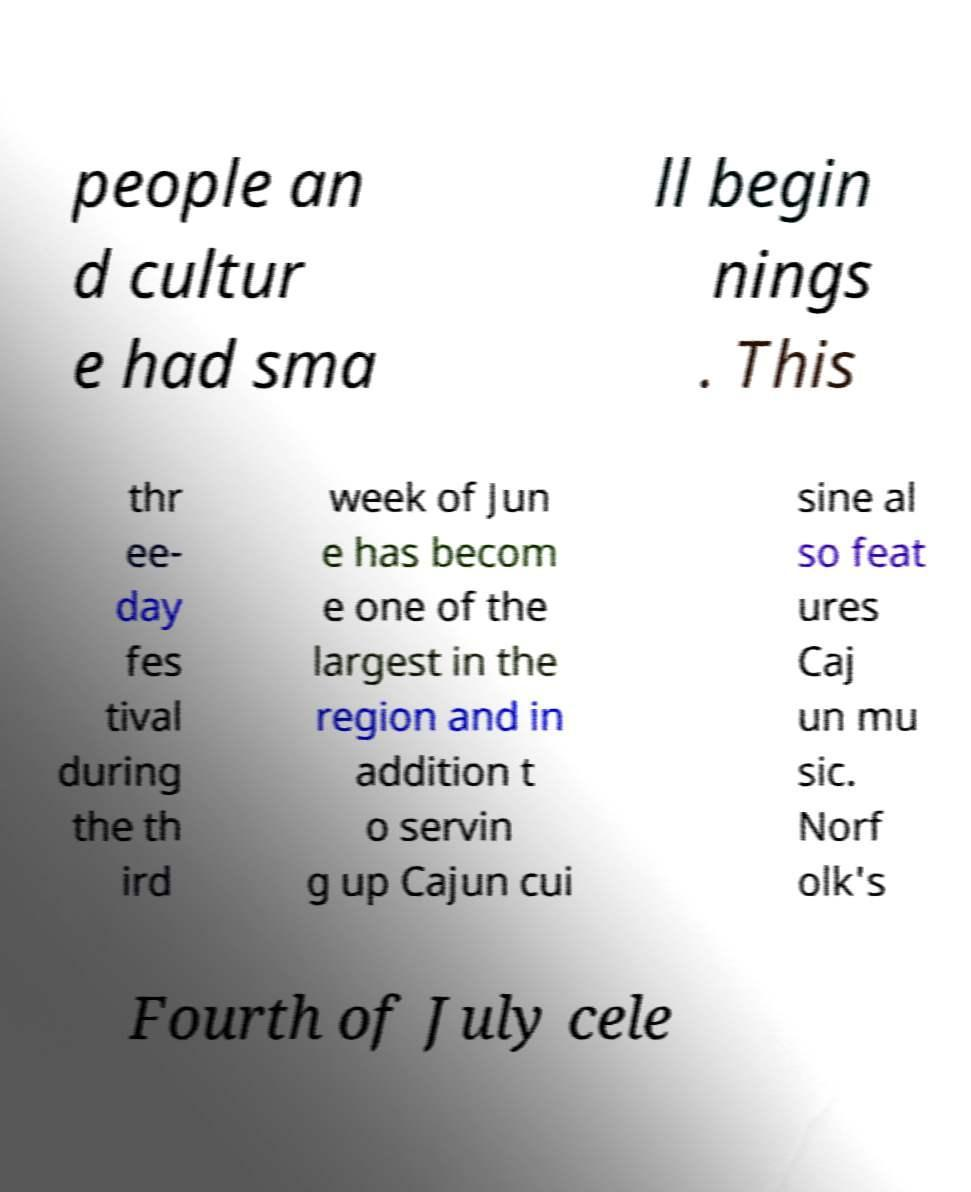Please identify and transcribe the text found in this image. people an d cultur e had sma ll begin nings . This thr ee- day fes tival during the th ird week of Jun e has becom e one of the largest in the region and in addition t o servin g up Cajun cui sine al so feat ures Caj un mu sic. Norf olk's Fourth of July cele 